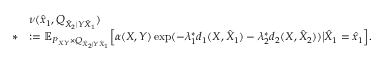<formula> <loc_0><loc_0><loc_500><loc_500>\begin{array} { r l } & { \nu ( \hat { x } _ { 1 } , Q _ { \hat { X } _ { 2 } | Y \hat { X } _ { 1 } } ) } \\ { * } & { \colon = \mathbb { E } _ { P _ { X Y } \times Q _ { \hat { X } _ { 2 } | Y \hat { X } _ { 1 } } } \Big [ \alpha ( X , Y ) \exp ( - \lambda _ { 1 } ^ { * } d _ { 1 } ( X , \hat { X } _ { 1 } ) - \lambda _ { 2 } ^ { * } d _ { 2 } ( X , \hat { X } _ { 2 } ) ) \Big | \hat { X } _ { 1 } = \hat { x } _ { 1 } \Big ] . } \end{array}</formula> 